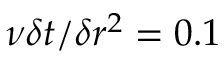Convert formula to latex. <formula><loc_0><loc_0><loc_500><loc_500>\nu \delta t / \delta r ^ { 2 } = 0 . 1</formula> 